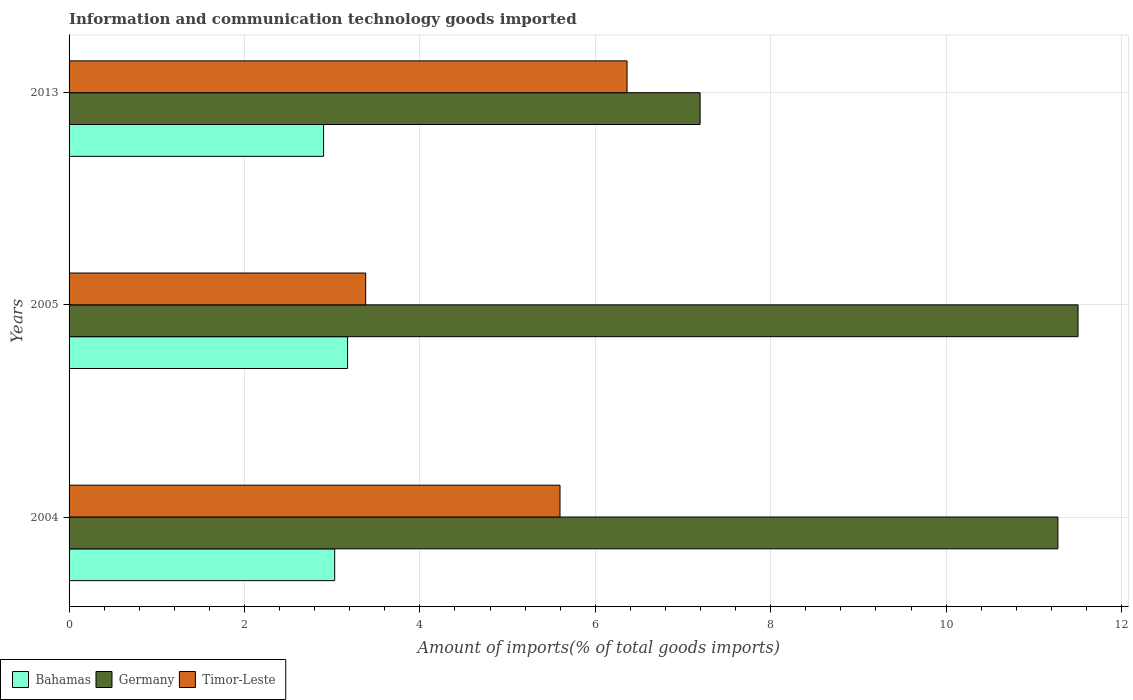How many different coloured bars are there?
Provide a short and direct response. 3. How many groups of bars are there?
Offer a very short reply. 3. How many bars are there on the 2nd tick from the bottom?
Provide a succinct answer. 3. What is the amount of goods imported in Bahamas in 2005?
Your answer should be compact. 3.18. Across all years, what is the maximum amount of goods imported in Bahamas?
Provide a short and direct response. 3.18. Across all years, what is the minimum amount of goods imported in Bahamas?
Ensure brevity in your answer.  2.9. In which year was the amount of goods imported in Timor-Leste maximum?
Offer a terse response. 2013. What is the total amount of goods imported in Germany in the graph?
Your answer should be very brief. 29.97. What is the difference between the amount of goods imported in Bahamas in 2004 and that in 2013?
Make the answer very short. 0.13. What is the difference between the amount of goods imported in Bahamas in 2004 and the amount of goods imported in Germany in 2005?
Provide a succinct answer. -8.48. What is the average amount of goods imported in Timor-Leste per year?
Make the answer very short. 5.11. In the year 2004, what is the difference between the amount of goods imported in Germany and amount of goods imported in Timor-Leste?
Your answer should be compact. 5.68. What is the ratio of the amount of goods imported in Germany in 2004 to that in 2005?
Provide a succinct answer. 0.98. What is the difference between the highest and the second highest amount of goods imported in Germany?
Keep it short and to the point. 0.23. What is the difference between the highest and the lowest amount of goods imported in Bahamas?
Your response must be concise. 0.27. Is the sum of the amount of goods imported in Germany in 2004 and 2005 greater than the maximum amount of goods imported in Timor-Leste across all years?
Provide a short and direct response. Yes. What does the 1st bar from the top in 2004 represents?
Offer a terse response. Timor-Leste. What does the 1st bar from the bottom in 2004 represents?
Provide a short and direct response. Bahamas. Is it the case that in every year, the sum of the amount of goods imported in Bahamas and amount of goods imported in Timor-Leste is greater than the amount of goods imported in Germany?
Offer a terse response. No. What is the difference between two consecutive major ticks on the X-axis?
Your response must be concise. 2. Are the values on the major ticks of X-axis written in scientific E-notation?
Offer a very short reply. No. Where does the legend appear in the graph?
Your answer should be very brief. Bottom left. How are the legend labels stacked?
Your answer should be compact. Horizontal. What is the title of the graph?
Make the answer very short. Information and communication technology goods imported. Does "Tajikistan" appear as one of the legend labels in the graph?
Keep it short and to the point. No. What is the label or title of the X-axis?
Ensure brevity in your answer.  Amount of imports(% of total goods imports). What is the label or title of the Y-axis?
Your response must be concise. Years. What is the Amount of imports(% of total goods imports) of Bahamas in 2004?
Your answer should be compact. 3.03. What is the Amount of imports(% of total goods imports) in Germany in 2004?
Offer a very short reply. 11.27. What is the Amount of imports(% of total goods imports) of Timor-Leste in 2004?
Provide a succinct answer. 5.6. What is the Amount of imports(% of total goods imports) in Bahamas in 2005?
Offer a very short reply. 3.18. What is the Amount of imports(% of total goods imports) of Germany in 2005?
Make the answer very short. 11.5. What is the Amount of imports(% of total goods imports) in Timor-Leste in 2005?
Your answer should be very brief. 3.38. What is the Amount of imports(% of total goods imports) in Bahamas in 2013?
Offer a terse response. 2.9. What is the Amount of imports(% of total goods imports) of Germany in 2013?
Your answer should be compact. 7.2. What is the Amount of imports(% of total goods imports) of Timor-Leste in 2013?
Provide a short and direct response. 6.36. Across all years, what is the maximum Amount of imports(% of total goods imports) in Bahamas?
Your answer should be compact. 3.18. Across all years, what is the maximum Amount of imports(% of total goods imports) of Germany?
Your response must be concise. 11.5. Across all years, what is the maximum Amount of imports(% of total goods imports) in Timor-Leste?
Provide a succinct answer. 6.36. Across all years, what is the minimum Amount of imports(% of total goods imports) in Bahamas?
Your answer should be compact. 2.9. Across all years, what is the minimum Amount of imports(% of total goods imports) of Germany?
Your answer should be very brief. 7.2. Across all years, what is the minimum Amount of imports(% of total goods imports) in Timor-Leste?
Offer a very short reply. 3.38. What is the total Amount of imports(% of total goods imports) in Bahamas in the graph?
Provide a succinct answer. 9.11. What is the total Amount of imports(% of total goods imports) in Germany in the graph?
Make the answer very short. 29.97. What is the total Amount of imports(% of total goods imports) in Timor-Leste in the graph?
Provide a succinct answer. 15.34. What is the difference between the Amount of imports(% of total goods imports) in Bahamas in 2004 and that in 2005?
Your answer should be compact. -0.15. What is the difference between the Amount of imports(% of total goods imports) of Germany in 2004 and that in 2005?
Provide a short and direct response. -0.23. What is the difference between the Amount of imports(% of total goods imports) of Timor-Leste in 2004 and that in 2005?
Provide a succinct answer. 2.22. What is the difference between the Amount of imports(% of total goods imports) of Bahamas in 2004 and that in 2013?
Your answer should be very brief. 0.13. What is the difference between the Amount of imports(% of total goods imports) of Germany in 2004 and that in 2013?
Provide a short and direct response. 4.08. What is the difference between the Amount of imports(% of total goods imports) in Timor-Leste in 2004 and that in 2013?
Give a very brief answer. -0.76. What is the difference between the Amount of imports(% of total goods imports) in Bahamas in 2005 and that in 2013?
Ensure brevity in your answer.  0.27. What is the difference between the Amount of imports(% of total goods imports) of Germany in 2005 and that in 2013?
Your answer should be very brief. 4.31. What is the difference between the Amount of imports(% of total goods imports) of Timor-Leste in 2005 and that in 2013?
Keep it short and to the point. -2.98. What is the difference between the Amount of imports(% of total goods imports) of Bahamas in 2004 and the Amount of imports(% of total goods imports) of Germany in 2005?
Make the answer very short. -8.48. What is the difference between the Amount of imports(% of total goods imports) in Bahamas in 2004 and the Amount of imports(% of total goods imports) in Timor-Leste in 2005?
Make the answer very short. -0.35. What is the difference between the Amount of imports(% of total goods imports) in Germany in 2004 and the Amount of imports(% of total goods imports) in Timor-Leste in 2005?
Provide a short and direct response. 7.89. What is the difference between the Amount of imports(% of total goods imports) of Bahamas in 2004 and the Amount of imports(% of total goods imports) of Germany in 2013?
Your response must be concise. -4.17. What is the difference between the Amount of imports(% of total goods imports) in Bahamas in 2004 and the Amount of imports(% of total goods imports) in Timor-Leste in 2013?
Provide a succinct answer. -3.33. What is the difference between the Amount of imports(% of total goods imports) in Germany in 2004 and the Amount of imports(% of total goods imports) in Timor-Leste in 2013?
Your answer should be very brief. 4.91. What is the difference between the Amount of imports(% of total goods imports) of Bahamas in 2005 and the Amount of imports(% of total goods imports) of Germany in 2013?
Your answer should be compact. -4.02. What is the difference between the Amount of imports(% of total goods imports) in Bahamas in 2005 and the Amount of imports(% of total goods imports) in Timor-Leste in 2013?
Give a very brief answer. -3.19. What is the difference between the Amount of imports(% of total goods imports) of Germany in 2005 and the Amount of imports(% of total goods imports) of Timor-Leste in 2013?
Offer a very short reply. 5.14. What is the average Amount of imports(% of total goods imports) in Bahamas per year?
Keep it short and to the point. 3.04. What is the average Amount of imports(% of total goods imports) in Germany per year?
Your answer should be very brief. 9.99. What is the average Amount of imports(% of total goods imports) of Timor-Leste per year?
Offer a very short reply. 5.11. In the year 2004, what is the difference between the Amount of imports(% of total goods imports) in Bahamas and Amount of imports(% of total goods imports) in Germany?
Keep it short and to the point. -8.25. In the year 2004, what is the difference between the Amount of imports(% of total goods imports) of Bahamas and Amount of imports(% of total goods imports) of Timor-Leste?
Provide a short and direct response. -2.57. In the year 2004, what is the difference between the Amount of imports(% of total goods imports) in Germany and Amount of imports(% of total goods imports) in Timor-Leste?
Your response must be concise. 5.68. In the year 2005, what is the difference between the Amount of imports(% of total goods imports) of Bahamas and Amount of imports(% of total goods imports) of Germany?
Offer a terse response. -8.33. In the year 2005, what is the difference between the Amount of imports(% of total goods imports) in Bahamas and Amount of imports(% of total goods imports) in Timor-Leste?
Your response must be concise. -0.21. In the year 2005, what is the difference between the Amount of imports(% of total goods imports) of Germany and Amount of imports(% of total goods imports) of Timor-Leste?
Provide a short and direct response. 8.12. In the year 2013, what is the difference between the Amount of imports(% of total goods imports) in Bahamas and Amount of imports(% of total goods imports) in Germany?
Provide a short and direct response. -4.29. In the year 2013, what is the difference between the Amount of imports(% of total goods imports) of Bahamas and Amount of imports(% of total goods imports) of Timor-Leste?
Your response must be concise. -3.46. In the year 2013, what is the difference between the Amount of imports(% of total goods imports) in Germany and Amount of imports(% of total goods imports) in Timor-Leste?
Provide a short and direct response. 0.83. What is the ratio of the Amount of imports(% of total goods imports) in Bahamas in 2004 to that in 2005?
Keep it short and to the point. 0.95. What is the ratio of the Amount of imports(% of total goods imports) in Germany in 2004 to that in 2005?
Give a very brief answer. 0.98. What is the ratio of the Amount of imports(% of total goods imports) of Timor-Leste in 2004 to that in 2005?
Offer a terse response. 1.66. What is the ratio of the Amount of imports(% of total goods imports) of Bahamas in 2004 to that in 2013?
Your answer should be very brief. 1.04. What is the ratio of the Amount of imports(% of total goods imports) in Germany in 2004 to that in 2013?
Provide a short and direct response. 1.57. What is the ratio of the Amount of imports(% of total goods imports) in Timor-Leste in 2004 to that in 2013?
Your answer should be compact. 0.88. What is the ratio of the Amount of imports(% of total goods imports) in Bahamas in 2005 to that in 2013?
Offer a terse response. 1.09. What is the ratio of the Amount of imports(% of total goods imports) in Germany in 2005 to that in 2013?
Your answer should be very brief. 1.6. What is the ratio of the Amount of imports(% of total goods imports) of Timor-Leste in 2005 to that in 2013?
Give a very brief answer. 0.53. What is the difference between the highest and the second highest Amount of imports(% of total goods imports) of Bahamas?
Give a very brief answer. 0.15. What is the difference between the highest and the second highest Amount of imports(% of total goods imports) of Germany?
Your response must be concise. 0.23. What is the difference between the highest and the second highest Amount of imports(% of total goods imports) in Timor-Leste?
Your answer should be very brief. 0.76. What is the difference between the highest and the lowest Amount of imports(% of total goods imports) in Bahamas?
Keep it short and to the point. 0.27. What is the difference between the highest and the lowest Amount of imports(% of total goods imports) in Germany?
Provide a short and direct response. 4.31. What is the difference between the highest and the lowest Amount of imports(% of total goods imports) of Timor-Leste?
Your answer should be very brief. 2.98. 